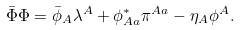<formula> <loc_0><loc_0><loc_500><loc_500>\bar { \Phi } \Phi = \bar { \phi } _ { A } \lambda ^ { A } + \phi _ { A a } ^ { \ast } \pi ^ { A a } - \eta _ { A } \phi ^ { A } .</formula> 